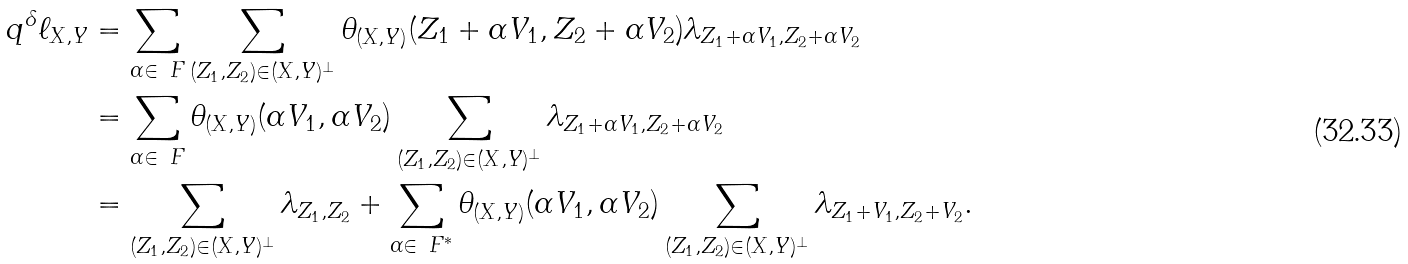<formula> <loc_0><loc_0><loc_500><loc_500>q ^ { \delta } \ell _ { X , Y } & = \sum _ { \alpha \in \ F } \sum _ { ( Z _ { 1 } , Z _ { 2 } ) \in ( X , Y ) ^ { \bot } } \theta _ { ( X , Y ) } ( Z _ { 1 } + \alpha V _ { 1 } , Z _ { 2 } + \alpha V _ { 2 } ) \lambda _ { Z _ { 1 } + \alpha V _ { 1 } , Z _ { 2 } + \alpha V _ { 2 } } \\ & = \sum _ { \alpha \in \ F } \theta _ { ( X , Y ) } ( \alpha V _ { 1 } , \alpha V _ { 2 } ) \sum _ { ( Z _ { 1 } , Z _ { 2 } ) \in ( X , Y ) ^ { \bot } } \lambda _ { Z _ { 1 } + \alpha V _ { 1 } , Z _ { 2 } + \alpha V _ { 2 } } \\ & = \sum _ { ( Z _ { 1 } , Z _ { 2 } ) \in ( X , Y ) ^ { \bot } } \lambda _ { Z _ { 1 } , Z _ { 2 } } + \sum _ { \alpha \in \ F ^ { * } } \theta _ { ( X , Y ) } ( \alpha V _ { 1 } , \alpha V _ { 2 } ) \sum _ { ( Z _ { 1 } , Z _ { 2 } ) \in ( X , Y ) ^ { \bot } } \lambda _ { Z _ { 1 } + V _ { 1 } , Z _ { 2 } + V _ { 2 } } .</formula> 